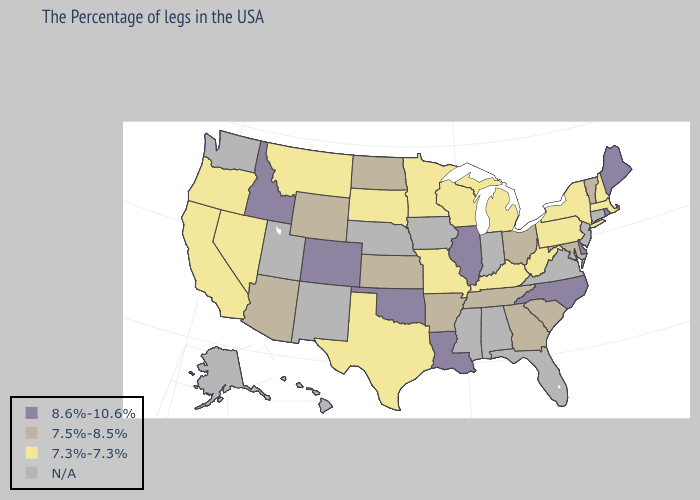What is the value of Maryland?
Quick response, please. 7.5%-8.5%. Name the states that have a value in the range 7.3%-7.3%?
Write a very short answer. Massachusetts, New Hampshire, New York, Pennsylvania, West Virginia, Michigan, Kentucky, Wisconsin, Missouri, Minnesota, Texas, South Dakota, Montana, Nevada, California, Oregon. Name the states that have a value in the range 8.6%-10.6%?
Keep it brief. Maine, Rhode Island, Delaware, North Carolina, Illinois, Louisiana, Oklahoma, Colorado, Idaho. What is the highest value in states that border Idaho?
Answer briefly. 7.5%-8.5%. Name the states that have a value in the range N/A?
Keep it brief. Connecticut, New Jersey, Virginia, Florida, Indiana, Alabama, Mississippi, Iowa, Nebraska, New Mexico, Utah, Washington, Alaska, Hawaii. Does the map have missing data?
Write a very short answer. Yes. Name the states that have a value in the range N/A?
Short answer required. Connecticut, New Jersey, Virginia, Florida, Indiana, Alabama, Mississippi, Iowa, Nebraska, New Mexico, Utah, Washington, Alaska, Hawaii. Name the states that have a value in the range 7.3%-7.3%?
Short answer required. Massachusetts, New Hampshire, New York, Pennsylvania, West Virginia, Michigan, Kentucky, Wisconsin, Missouri, Minnesota, Texas, South Dakota, Montana, Nevada, California, Oregon. What is the value of Utah?
Keep it brief. N/A. Which states have the lowest value in the USA?
Answer briefly. Massachusetts, New Hampshire, New York, Pennsylvania, West Virginia, Michigan, Kentucky, Wisconsin, Missouri, Minnesota, Texas, South Dakota, Montana, Nevada, California, Oregon. Among the states that border Arizona , which have the lowest value?
Short answer required. Nevada, California. What is the value of Delaware?
Give a very brief answer. 8.6%-10.6%. 